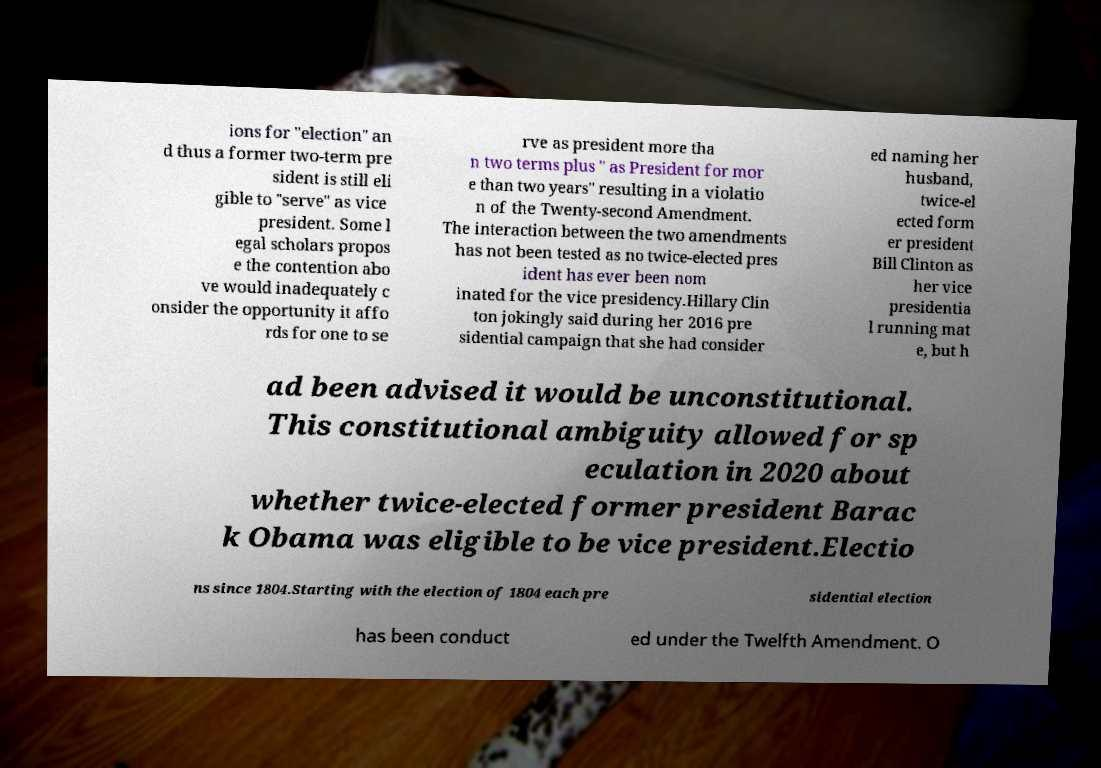Could you extract and type out the text from this image? ions for "election" an d thus a former two-term pre sident is still eli gible to "serve" as vice president. Some l egal scholars propos e the contention abo ve would inadequately c onsider the opportunity it affo rds for one to se rve as president more tha n two terms plus " as President for mor e than two years" resulting in a violatio n of the Twenty-second Amendment. The interaction between the two amendments has not been tested as no twice-elected pres ident has ever been nom inated for the vice presidency.Hillary Clin ton jokingly said during her 2016 pre sidential campaign that she had consider ed naming her husband, twice-el ected form er president Bill Clinton as her vice presidentia l running mat e, but h ad been advised it would be unconstitutional. This constitutional ambiguity allowed for sp eculation in 2020 about whether twice-elected former president Barac k Obama was eligible to be vice president.Electio ns since 1804.Starting with the election of 1804 each pre sidential election has been conduct ed under the Twelfth Amendment. O 